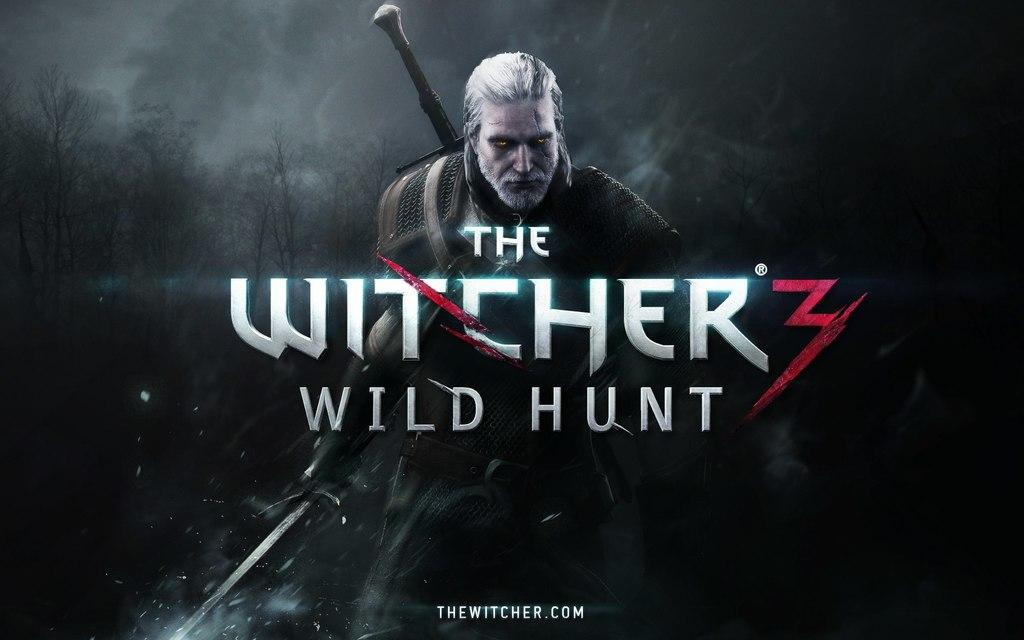<image>
Give a short and clear explanation of the subsequent image. The witcher three wild hunt movie with the cover 